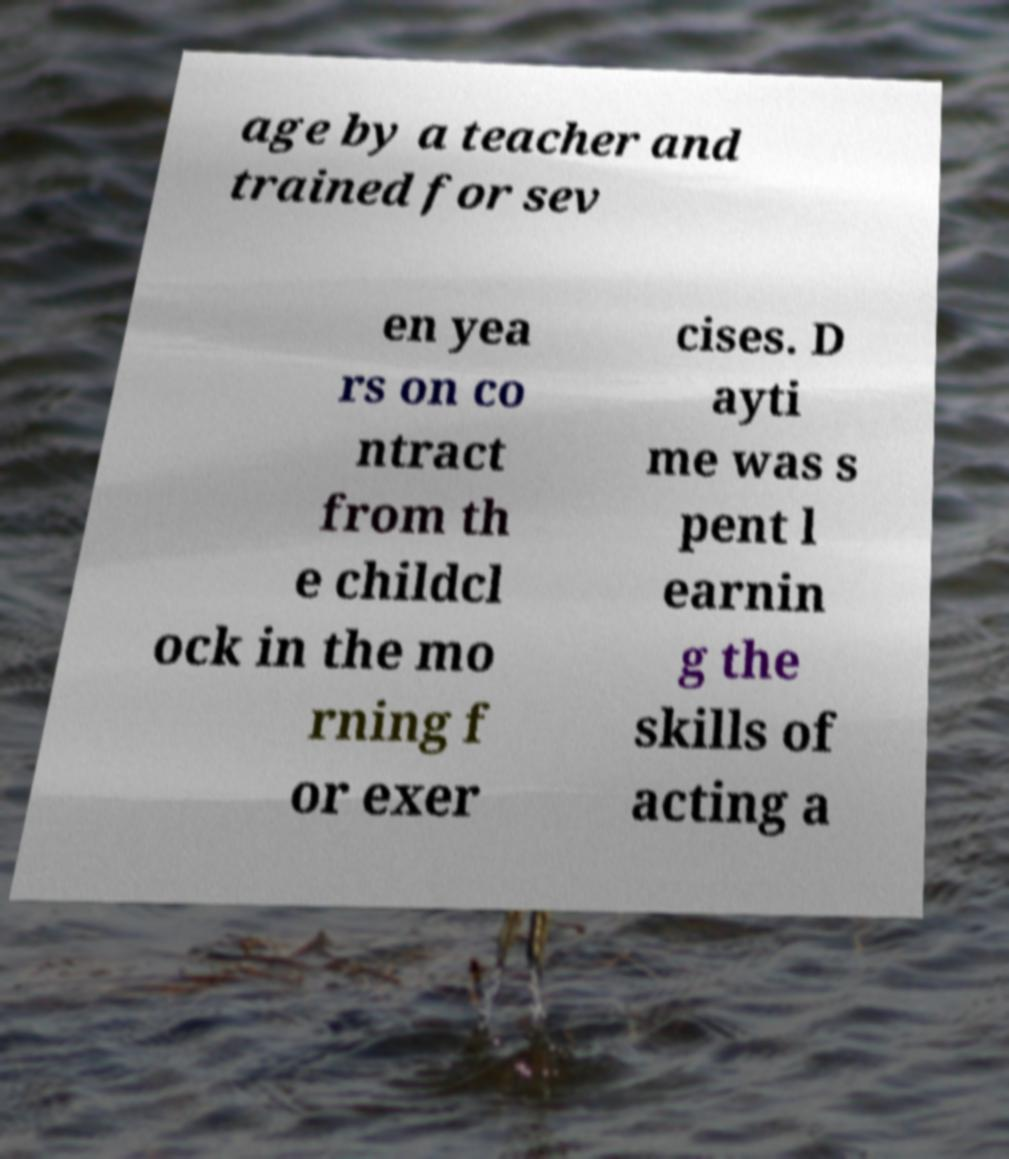For documentation purposes, I need the text within this image transcribed. Could you provide that? age by a teacher and trained for sev en yea rs on co ntract from th e childcl ock in the mo rning f or exer cises. D ayti me was s pent l earnin g the skills of acting a 